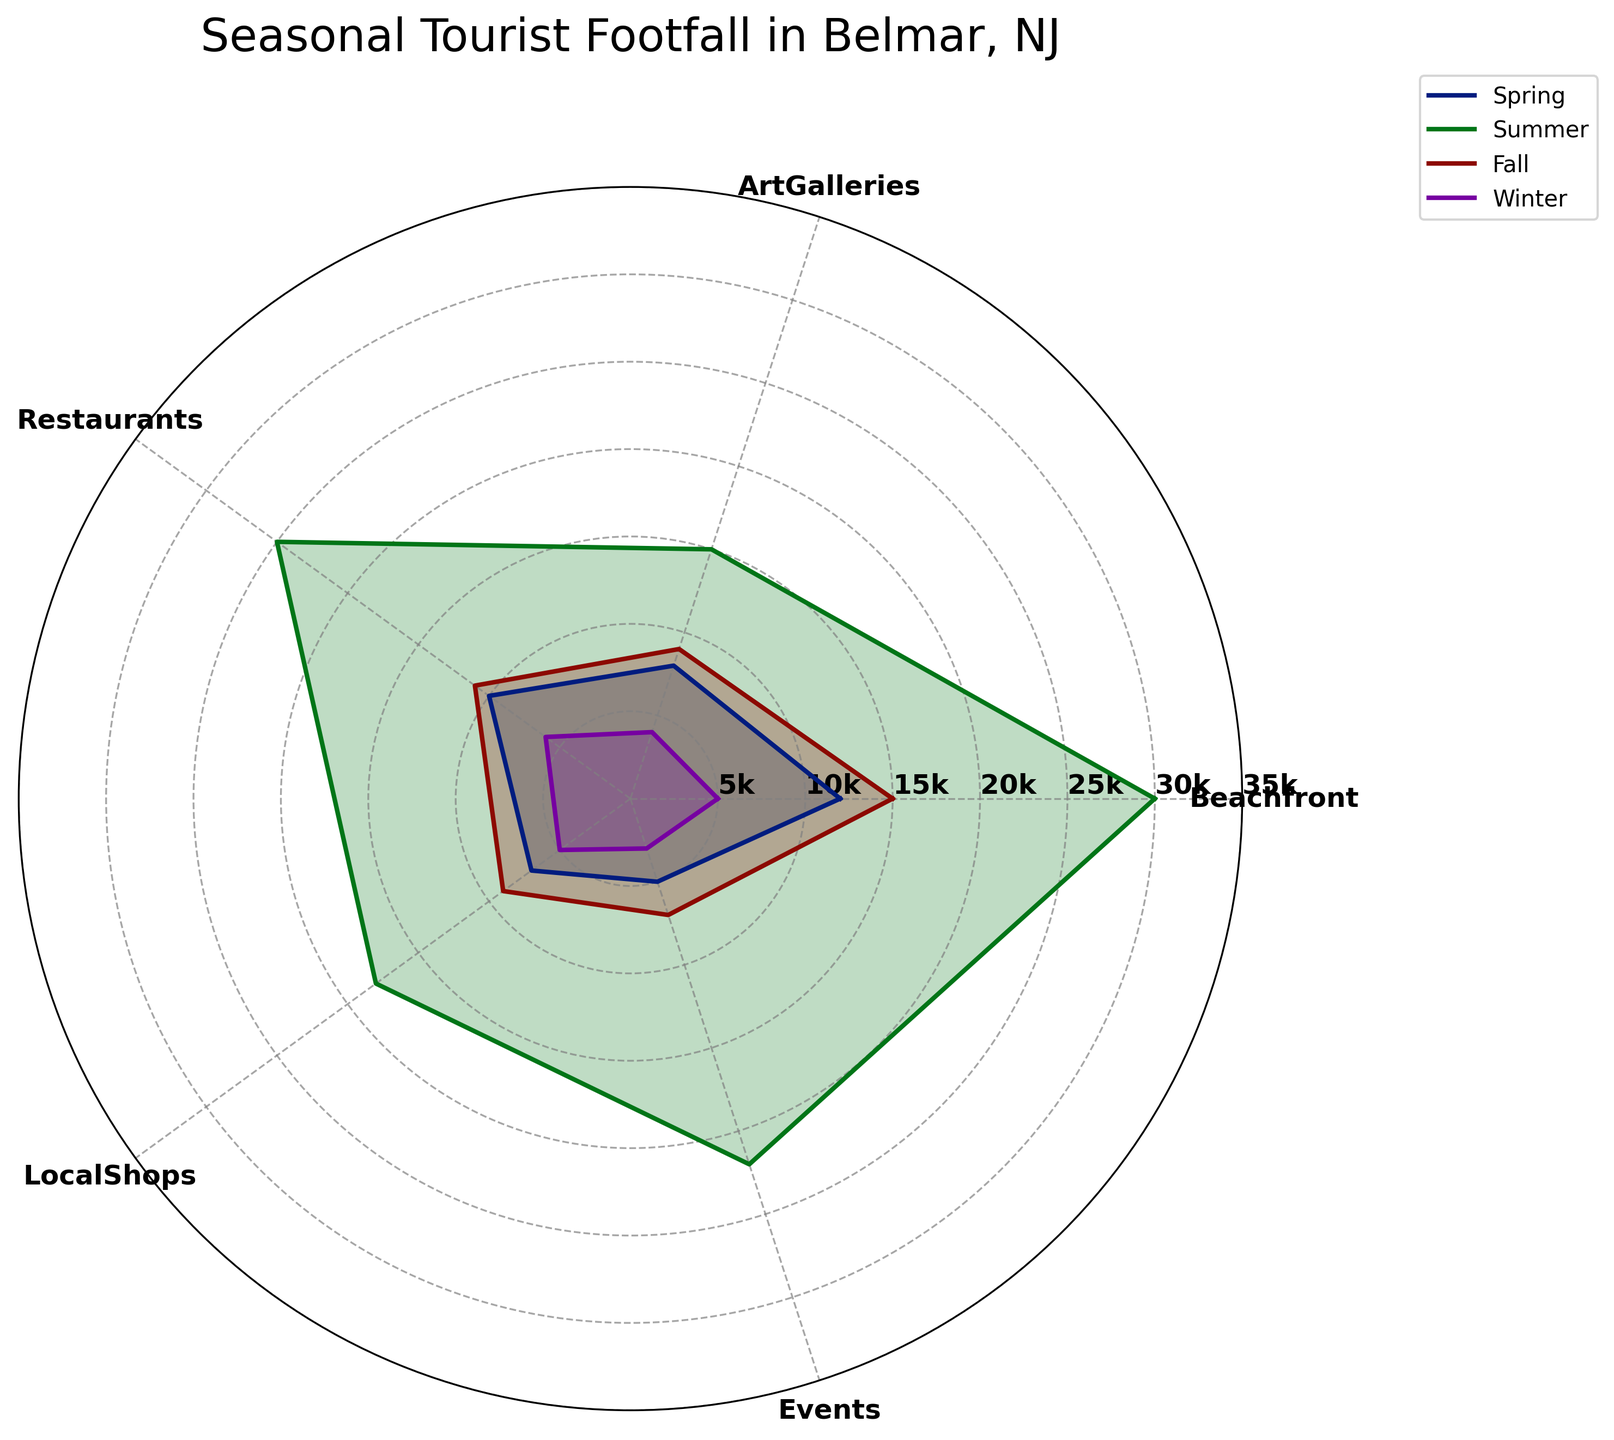What is the highest tourist footfall recorded in any category? Analyze the radar chart and identify the peak value across all categories and seasons. Compare the heights of the areas filled within the plot.
Answer: 30,000 (Summer Beachfront) What season has the lowest tourist footfall in art galleries? Refer to the line or filled area corresponding to the Art Galleries category and find the lowest point within the seasons marked on the radar chart.
Answer: Winter How does the tourist footfall in local shops during the fall compare to that in the summer? Look at the point on the radar chart for LocalShops in both Summer and Fall. Compare the height or size of the filled shape at each season's marker.
Answer: Fall is lower than Summer Which category shows the most significant difference between summer and winter? Observe the differences in the lengths of the lines reaching out from the center for summer and winter in each category and pinpoint the one with the largest gap.
Answer: Beachfront What is the average footfall for restaurants across all seasons? Find the footfall numbers for the Restaurants category in each season (Spring: 10000, Summer: 25000, Fall: 11000, Winter: 6000) and calculate the average: (10000+25000+11000+6000)/4 = 13000
Answer: 13000 Which season has the most balanced tourist distribution across all categories? Examine the radar chart and assess the areas (polygons) covered by each season's data. Look for the season where the plot is most evenly spread out towards all categories.
Answer: Fall Are there any categories where the footfall is consistently increasing from winter to summer? For each category, follow the progression from Winter to Spring to Summer, checking if the values increase at every step.
Answer: Yes, Beachfront and Restaurants What's the combined tourist footfall for events and beachfront in spring? Look at the radar chart and note the footfall numbers for Events and Beachfront during Spring, then add them together: 5000 (Events) + 12000 (Beachfront).
Answer: 17000 Is the local shops footfall in spring higher or lower than the beachfront footfall in winter? Locate the values for Local Shops in Spring and Beachfront in Winter on the radar chart and compare them directly.
Answer: Higher 